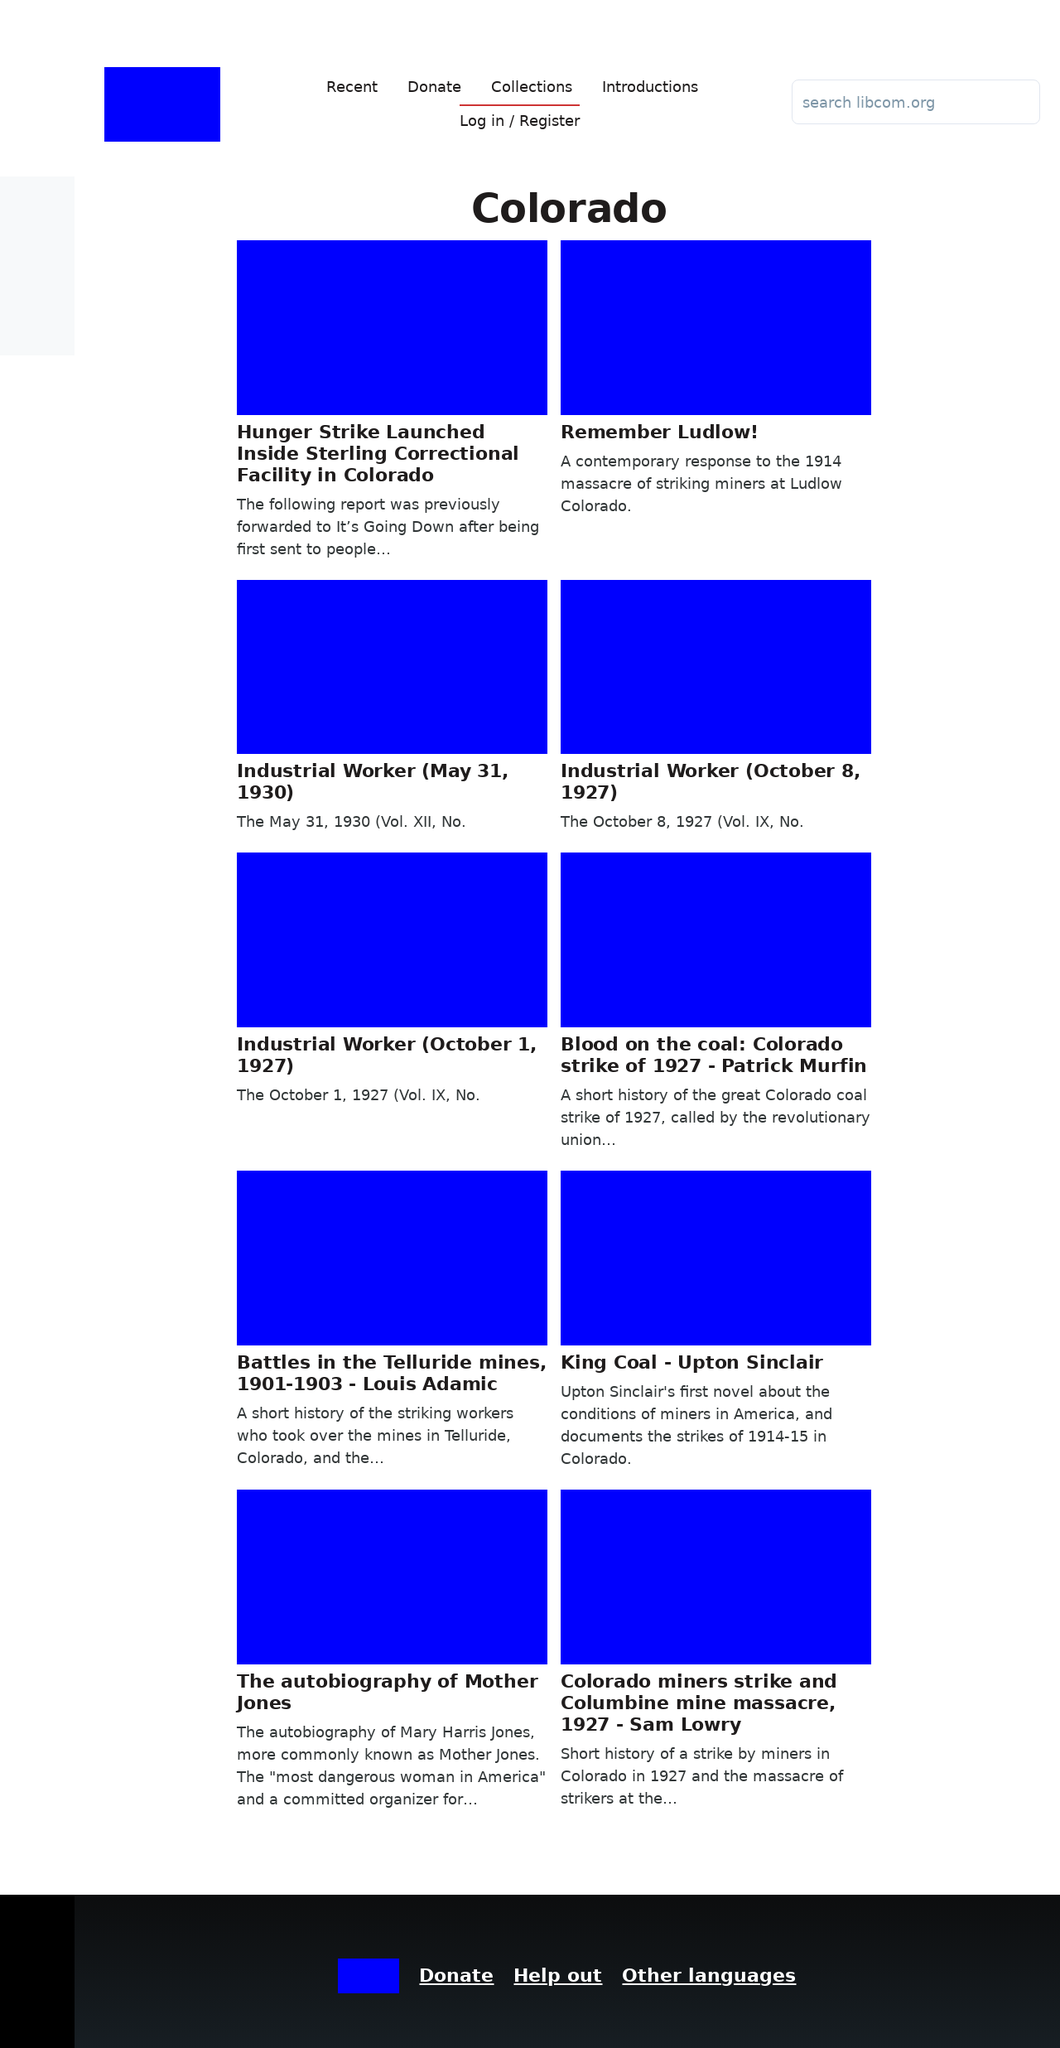Could you detail the process for assembling this website using HTML? To assemble a website like the one shown in the image using HTML, you would start by defining the structure with HTML tags such as <html>, <head>, <body>, etc., where you include essential elements like a navigation menu, main content area, and footer. You would use <header>, <main>, <footer> to structure these sections. Inside these, you can place <div> tags representing different content blocks/sections visible in the image (e.g., article list, donation button). CSS styles would then be applied to style and layout these elements. 